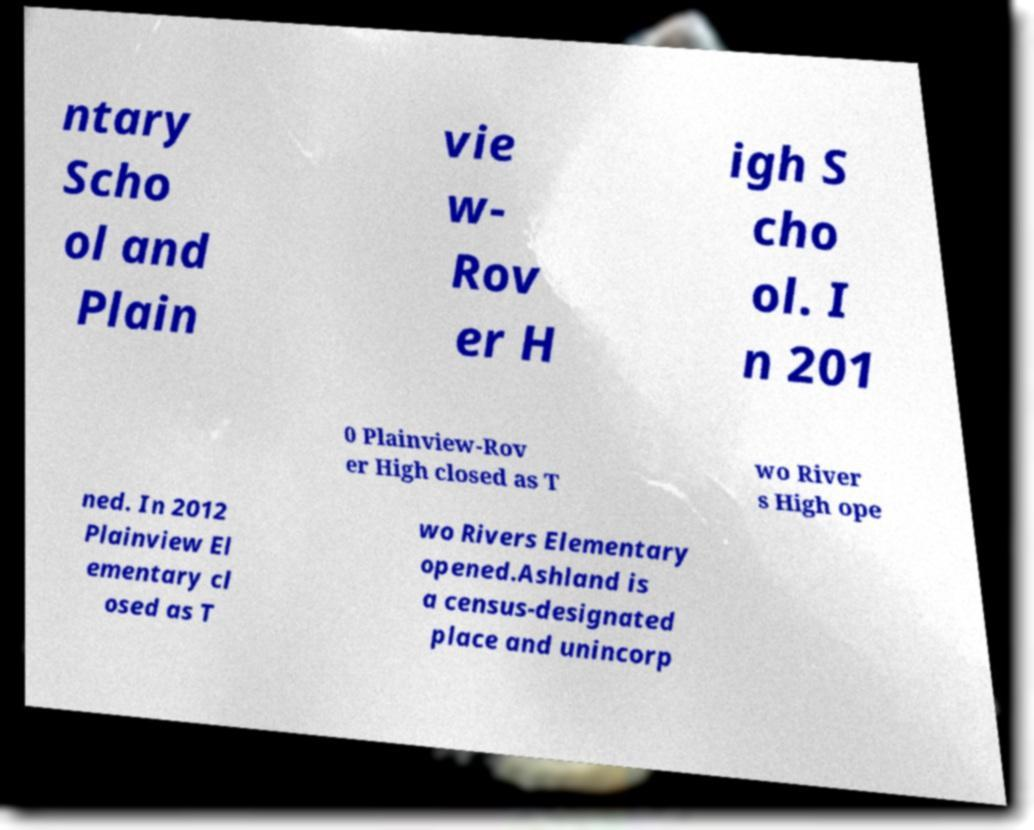Can you accurately transcribe the text from the provided image for me? ntary Scho ol and Plain vie w- Rov er H igh S cho ol. I n 201 0 Plainview-Rov er High closed as T wo River s High ope ned. In 2012 Plainview El ementary cl osed as T wo Rivers Elementary opened.Ashland is a census-designated place and unincorp 